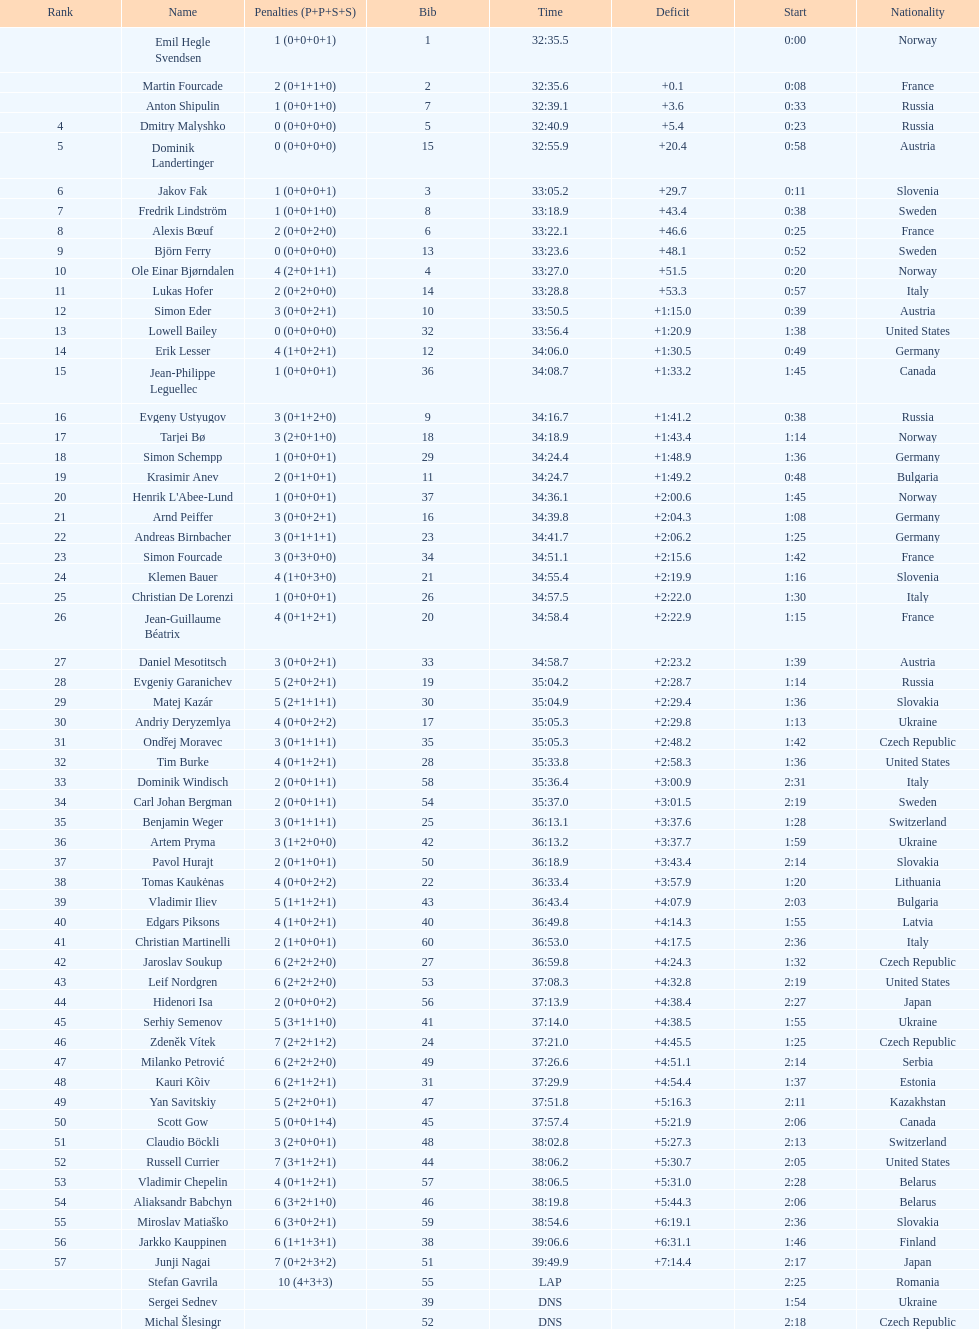Besides burke, identify an american sportsman or sportswoman. Leif Nordgren. 